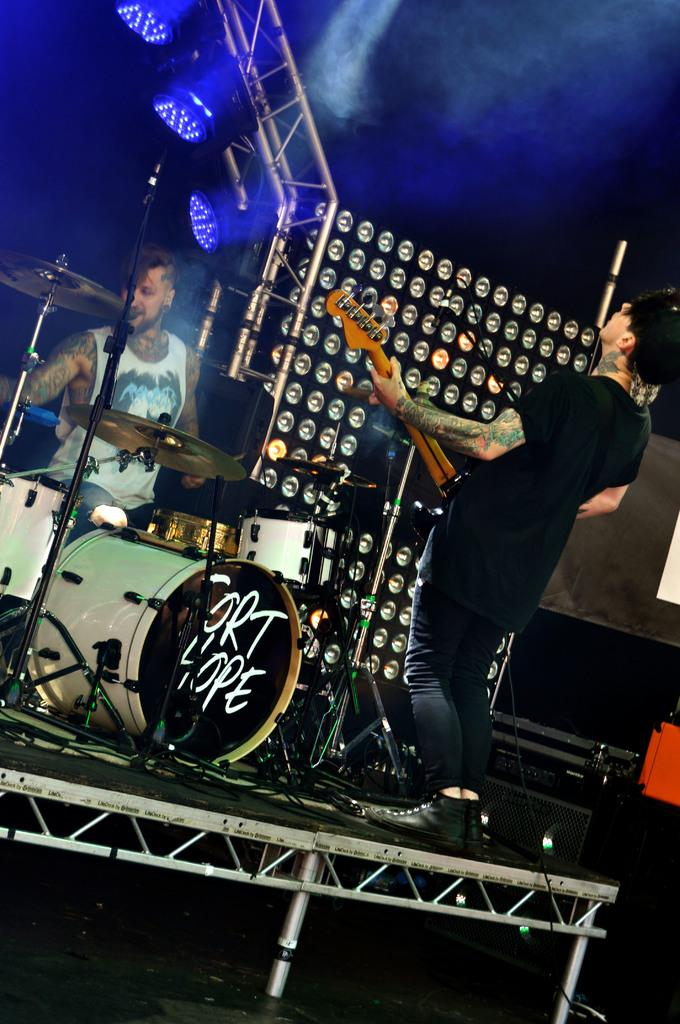How many people are on the stage in the image? There are two persons on the stage in the image. What is one person doing on the stage? One person is standing and playing a guitar. What is the other person doing on the stage? There is a man playing musical instruments. What can be seen in the background of the image? There are lights visible in the image. What type of nerve can be seen in the image? There is no nerve present in the image; it features two people playing musical instruments on a stage. Can you tell me how many leaves are on the guitar in the image? There are no leaves present in the image; it features a guitar being played by one of the persons on the stage. 